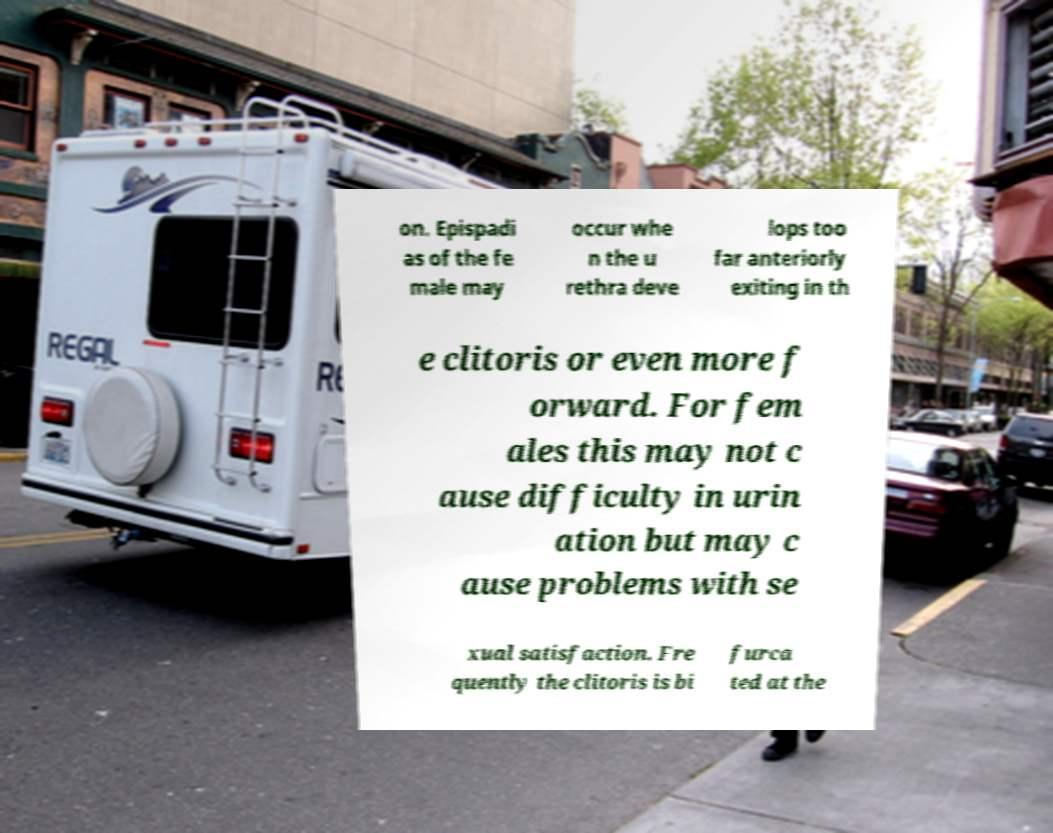Could you assist in decoding the text presented in this image and type it out clearly? on. Epispadi as of the fe male may occur whe n the u rethra deve lops too far anteriorly exiting in th e clitoris or even more f orward. For fem ales this may not c ause difficulty in urin ation but may c ause problems with se xual satisfaction. Fre quently the clitoris is bi furca ted at the 